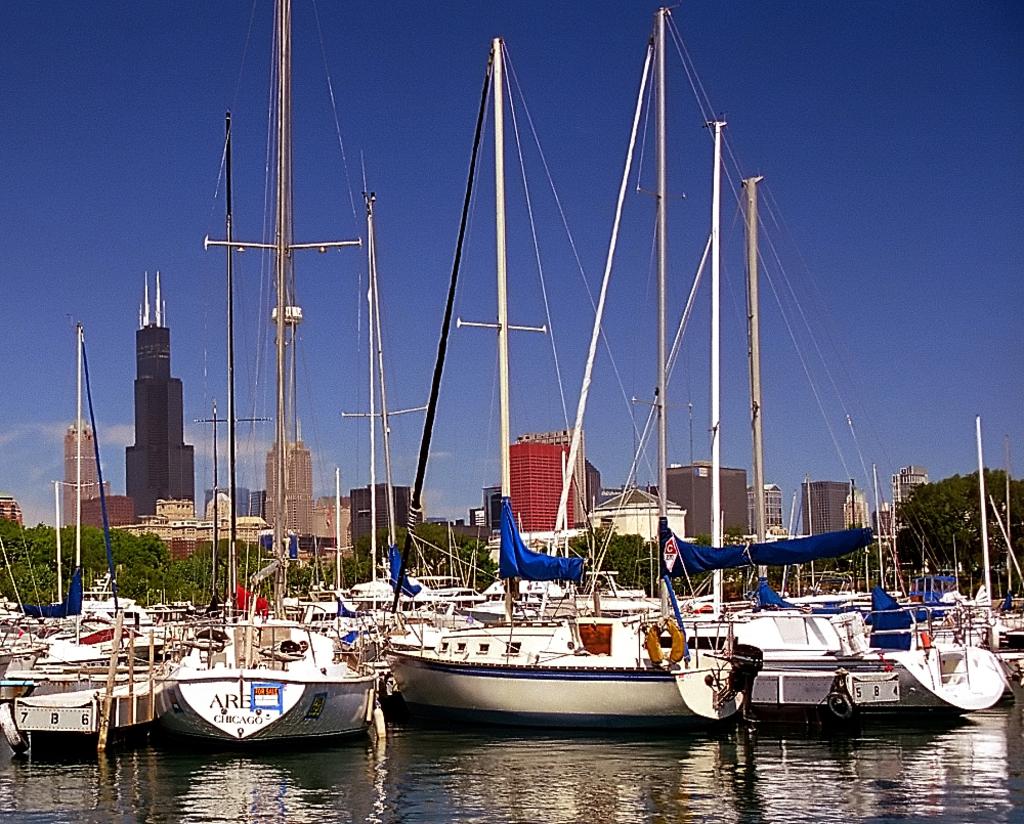Where is the sailboat on the left's home port?
Your answer should be compact. Chicago. What is one letter found on one of the boats?
Give a very brief answer. A. 